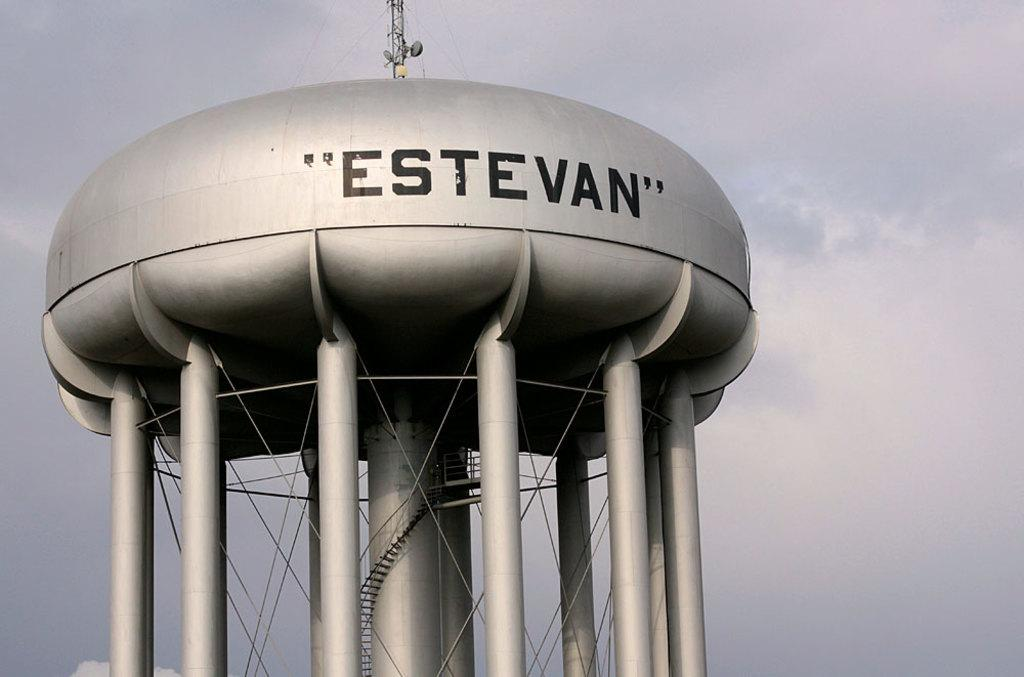<image>
Offer a succinct explanation of the picture presented. A large silver water tank reads "Estevan" on its side. 